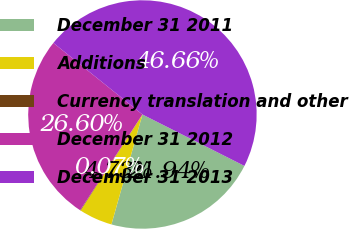<chart> <loc_0><loc_0><loc_500><loc_500><pie_chart><fcel>December 31 2011<fcel>Additions<fcel>Currency translation and other<fcel>December 31 2012<fcel>December 31 2013<nl><fcel>21.94%<fcel>4.73%<fcel>0.07%<fcel>26.6%<fcel>46.66%<nl></chart> 